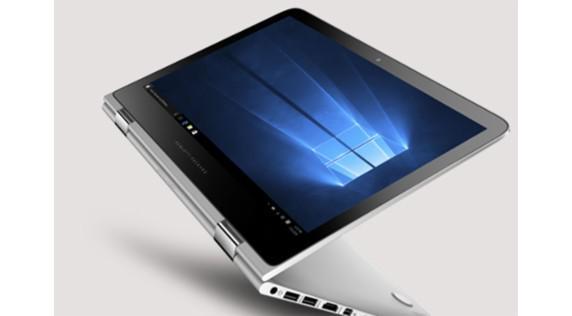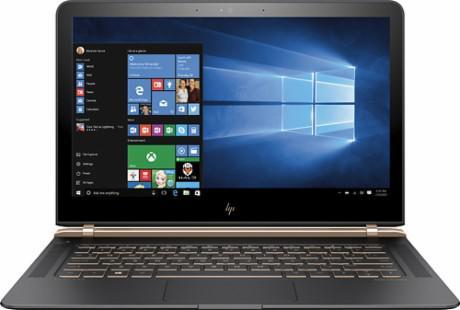The first image is the image on the left, the second image is the image on the right. Evaluate the accuracy of this statement regarding the images: "The laptop in the image on the left is facing forward.". Is it true? Answer yes or no. No. 